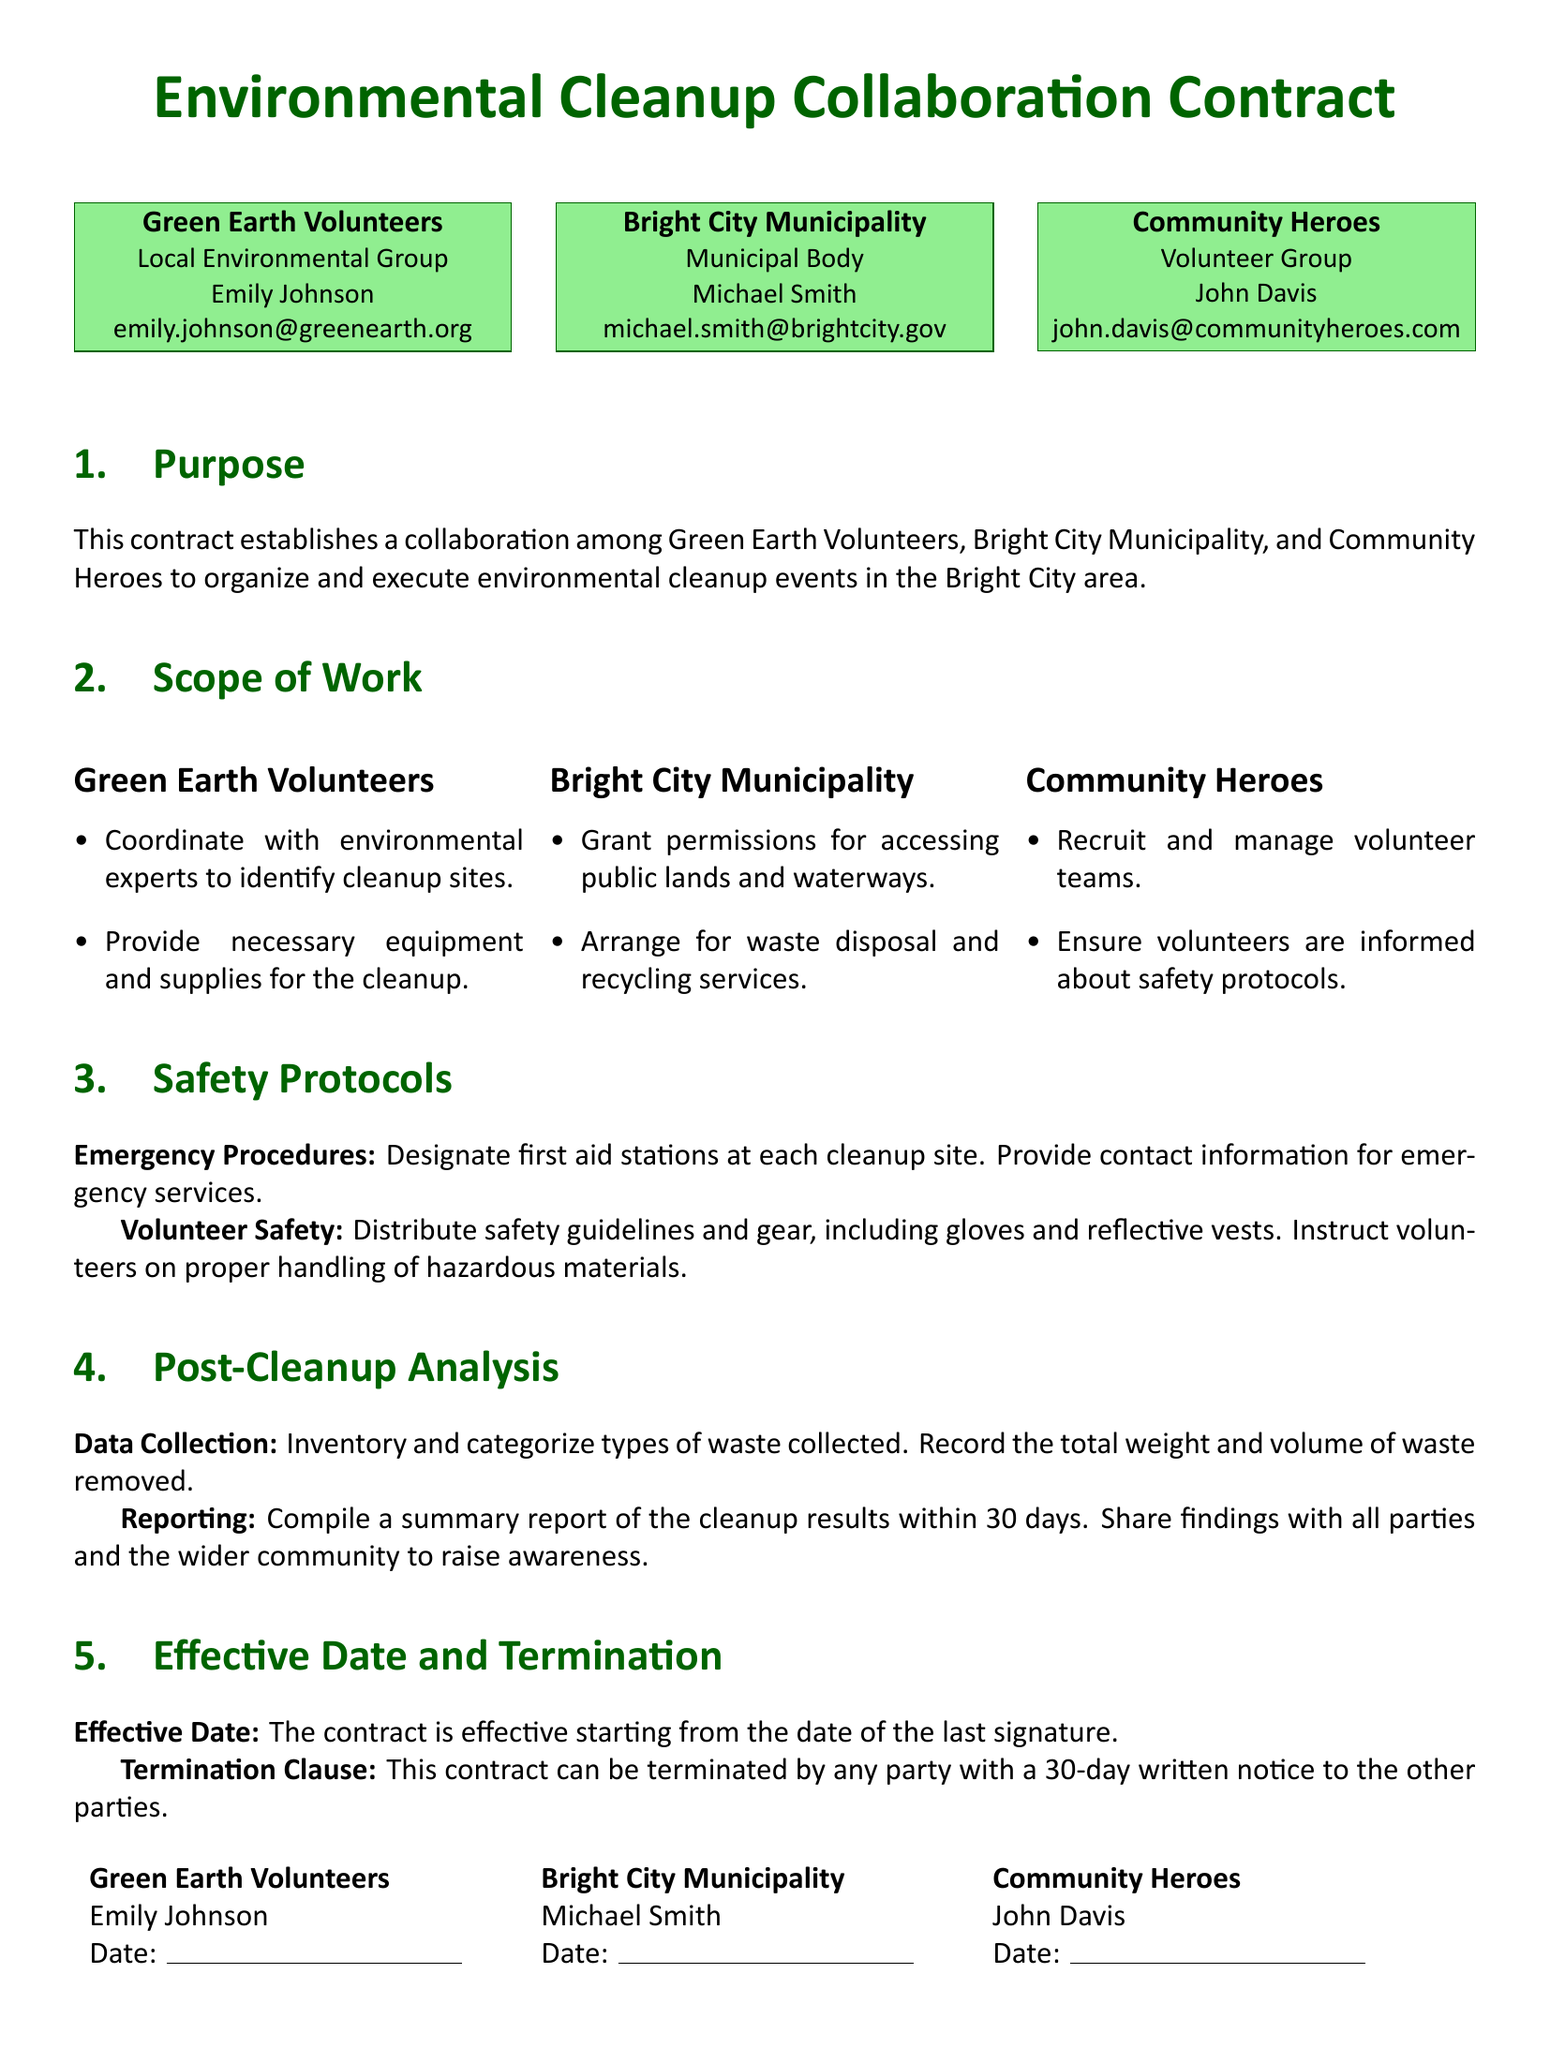What is the name of the local environmental group? The local environmental group involved in the contract is Green Earth Volunteers.
Answer: Green Earth Volunteers Who is the representative of the municipal body? The representative for the Bright City Municipality is Michael Smith.
Answer: Michael Smith What are the main responsibilities of Community Heroes? Community Heroes is responsible for recruiting and managing volunteer teams and ensuring they are informed about safety protocols.
Answer: Recruit and manage volunteer teams; ensure safety protocols How long does the contract allow for compiling a summary report after the cleanup? The contract specifies that the summary report of the cleanup results must be compiled within 30 days.
Answer: 30 days What safety gear is provided to volunteers? Volunteers are provided with gloves and reflective vests as part of safety protocols.
Answer: Gloves and reflective vests What must be done for waste disposal according to Bright City Municipality? The Bright City Municipality is responsible for arranging waste disposal and recycling services during the events.
Answer: Arrange for waste disposal and recycling services How is the effective date of the contract determined? The effective date is determined by the date of the last signature on the contract.
Answer: Date of the last signature What must be designated at each cleanup site for emergencies? First aid stations must be designated at each cleanup site to handle emergencies.
Answer: First aid stations What is the termination notice period for the contract? Any party wishing to terminate the contract must provide a 30-day written notice to the other parties.
Answer: 30-day written notice 